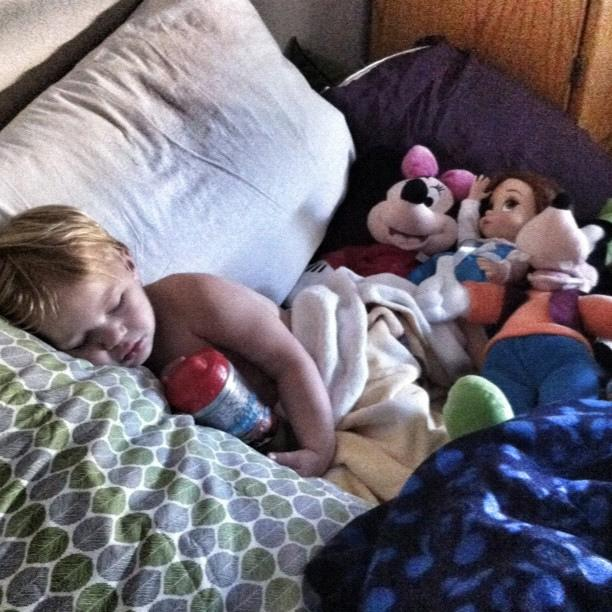In which one of these cities can you meet the characters shown here?

Choices:
A) fargo
B) hershey
C) trenton
D) anaheim anaheim 